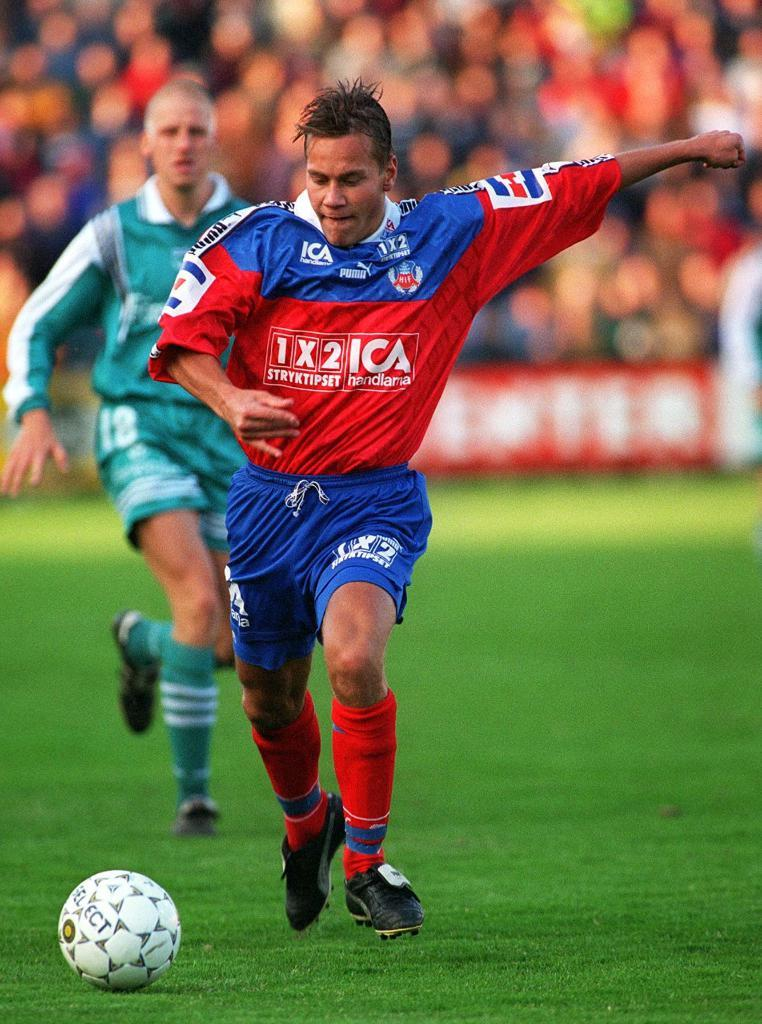<image>
Render a clear and concise summary of the photo. Two soccer players running after a Select brand ball. 